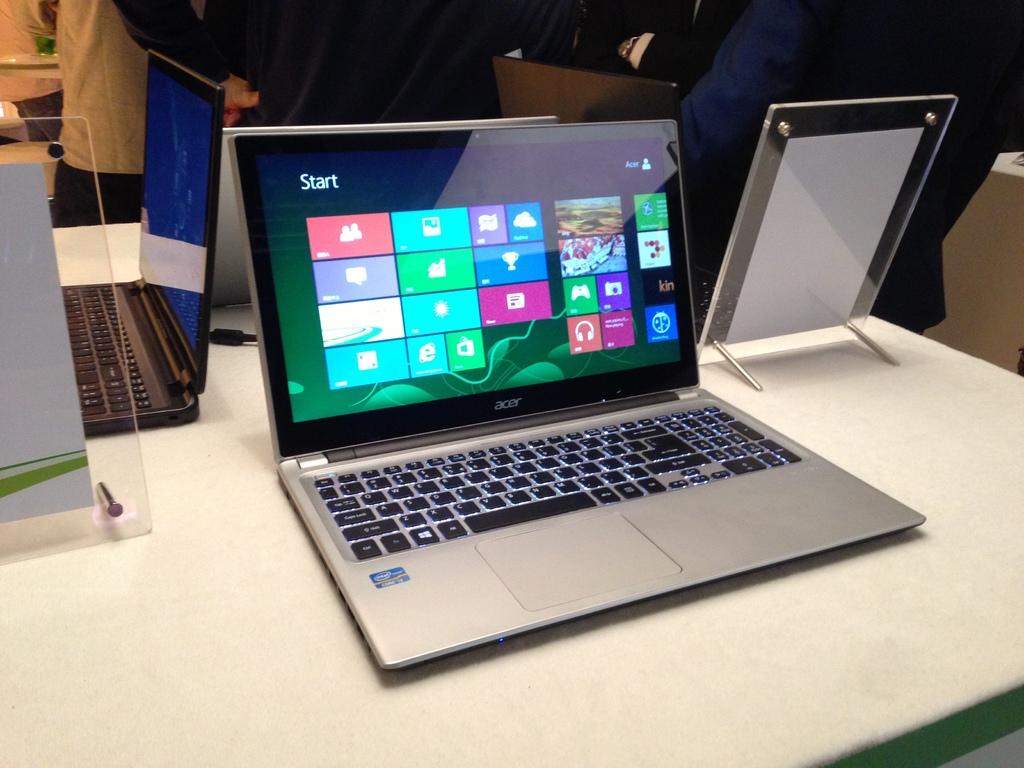<image>
Summarize the visual content of the image. A laptop with icons on the screen and "Start" at the top. 